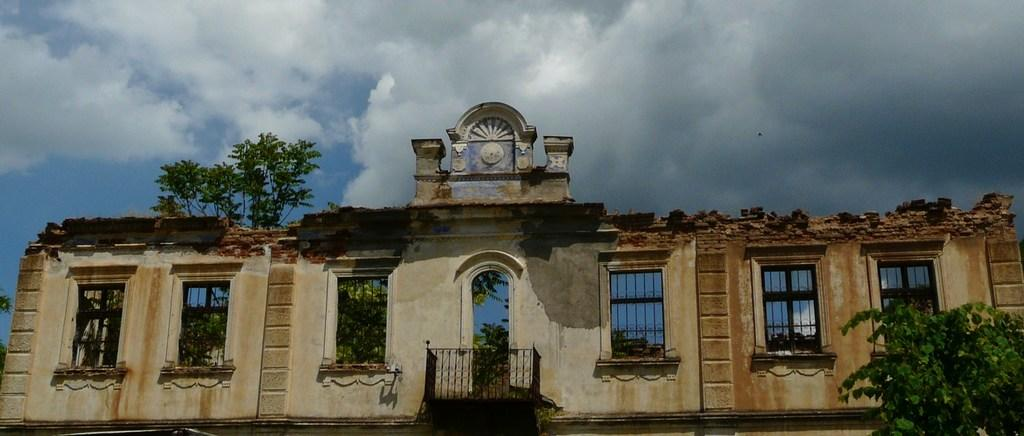What is located directly in front of the viewer in the image? There is a wall in front in the image. What feature can be seen on the wall? There are windows on the wall. What type of natural scenery is visible in the image? Trees are visible in the image. What can be seen in the distance in the image? The sky is visible in the background of the image. What is the weather like in the image? The sky is cloudy in the image. What type of cable can be seen running along the wall in the image? There is no cable visible running along the wall in the image. What is the opinion of the trees about the cloudy sky in the image? Trees do not have opinions, as they are inanimate objects. 